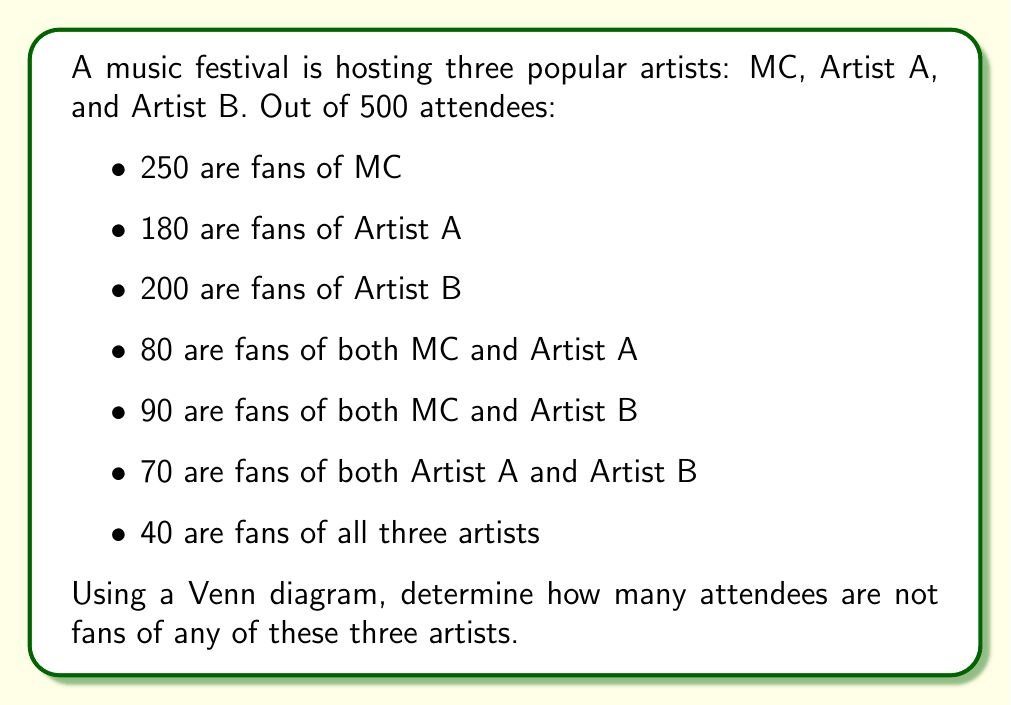Could you help me with this problem? Let's approach this step-by-step using a Venn diagram:

1) First, let's draw a Venn diagram with three overlapping circles representing MC, Artist A, and Artist B.

2) We'll fill in the known information:
   - The region where all three circles overlap: 40
   - MC ∩ A (not including B): 80 - 40 = 40
   - MC ∩ B (not including A): 90 - 40 = 50
   - A ∩ B (not including MC): 70 - 40 = 30
   
3) Now, let's calculate the remaining regions:
   - MC only: 250 - (40 + 40 + 50) = 120
   - A only: 180 - (40 + 40 + 30) = 70
   - B only: 200 - (40 + 50 + 30) = 80

4) Let's sum up all the regions in the Venn diagram:
   $$ 40 + 40 + 50 + 30 + 120 + 70 + 80 = 430 $$

5) The total number of attendees is 500, so the number of attendees not in any circle is:
   $$ 500 - 430 = 70 $$

Therefore, 70 attendees are not fans of any of these three artists.
Answer: 70 attendees 